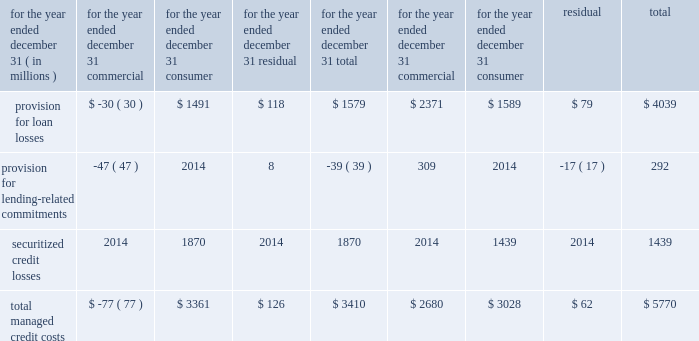J.p .
Morgan chase & co .
/ 2003 annual report 65 the commercial specific loss component of the allowance was $ 917 million at december 31 , 2003 , a decrease of 43% ( 43 % ) from year-end 2002 .
The decrease was attributable to the improve- ment in the credit quality of the commercial loan portfolio , as well as the reduction in the size of the portfolio .
The commercial expected loss component of the allowance was $ 454 million at december 31 , 2003 , a decrease of 26% ( 26 % ) from year- end 2002 .
The decrease reflected an improvement in the average quality of the loan portfolio , as well as the improving credit envi- ronment , which affected inputs to the expected loss model .
The consumer expected loss component of the allowance was $ 2.3 billion at december 31 , 2003 , a decrease of 4% ( 4 % ) from year- end 2002 .
Although the consumer managed loan portfolio increased by 10% ( 10 % ) , the businesses that drove the increase , home finance and auto finance , have collateralized products with lower expected loss rates .
The residual component of the allowance was $ 895 million at december 31 , 2003 .
The residual component , which incorpo- rates management's judgment , addresses uncertainties that are not considered in the formula-based commercial specific and expected components of the allowance for credit losses .
The $ 121 million increase addressed uncertainties in the eco- nomic environment and concentrations in the commercial loan portfolio that existed during the first half of 2003 .
In the sec- ond half of the year , as commercial credit quality continued to improve and the commercial allowance declined further , the residual component was reduced as well .
At december 31 , 2003 , the residual component represented approximately 20% ( 20 % ) of the total allowance for loan losses , within the firm 2019s target range of between 10% ( 10 % ) and 20% ( 20 % ) .
The firm anticipates that if the current positive trend in economic conditions and credit quality continues , the commercial and residual components will continue to be reduced .
Lending-related commitments to provide for the risk of loss inherent in the credit-extension process , management also computes specific and expected loss components as well as a residual component for commercial lending 2013related commitments .
This is computed using a methodology similar to that used for the commercial loan port- folio , modified for expected maturities and probabilities of drawdown .
The allowance decreased by 11% ( 11 % ) to $ 324 million as of december 31 , 2003 , due to improvement in the criticized portion of the firm 2019s lending-related commitments .
Credit costs .

The consumer segment accounted for how much of the overall provision for loan losses in 2003? 
Computations: (1491 / 1579)
Answer: 0.94427. J.p .
Morgan chase & co .
/ 2003 annual report 65 the commercial specific loss component of the allowance was $ 917 million at december 31 , 2003 , a decrease of 43% ( 43 % ) from year-end 2002 .
The decrease was attributable to the improve- ment in the credit quality of the commercial loan portfolio , as well as the reduction in the size of the portfolio .
The commercial expected loss component of the allowance was $ 454 million at december 31 , 2003 , a decrease of 26% ( 26 % ) from year- end 2002 .
The decrease reflected an improvement in the average quality of the loan portfolio , as well as the improving credit envi- ronment , which affected inputs to the expected loss model .
The consumer expected loss component of the allowance was $ 2.3 billion at december 31 , 2003 , a decrease of 4% ( 4 % ) from year- end 2002 .
Although the consumer managed loan portfolio increased by 10% ( 10 % ) , the businesses that drove the increase , home finance and auto finance , have collateralized products with lower expected loss rates .
The residual component of the allowance was $ 895 million at december 31 , 2003 .
The residual component , which incorpo- rates management's judgment , addresses uncertainties that are not considered in the formula-based commercial specific and expected components of the allowance for credit losses .
The $ 121 million increase addressed uncertainties in the eco- nomic environment and concentrations in the commercial loan portfolio that existed during the first half of 2003 .
In the sec- ond half of the year , as commercial credit quality continued to improve and the commercial allowance declined further , the residual component was reduced as well .
At december 31 , 2003 , the residual component represented approximately 20% ( 20 % ) of the total allowance for loan losses , within the firm 2019s target range of between 10% ( 10 % ) and 20% ( 20 % ) .
The firm anticipates that if the current positive trend in economic conditions and credit quality continues , the commercial and residual components will continue to be reduced .
Lending-related commitments to provide for the risk of loss inherent in the credit-extension process , management also computes specific and expected loss components as well as a residual component for commercial lending 2013related commitments .
This is computed using a methodology similar to that used for the commercial loan port- folio , modified for expected maturities and probabilities of drawdown .
The allowance decreased by 11% ( 11 % ) to $ 324 million as of december 31 , 2003 , due to improvement in the criticized portion of the firm 2019s lending-related commitments .
Credit costs .

What was the consumer expected loss allowance at 12/31/2002 , in billions? 
Computations: (2.3 / ((100 - 4) / 100))
Answer: 2.39583. 